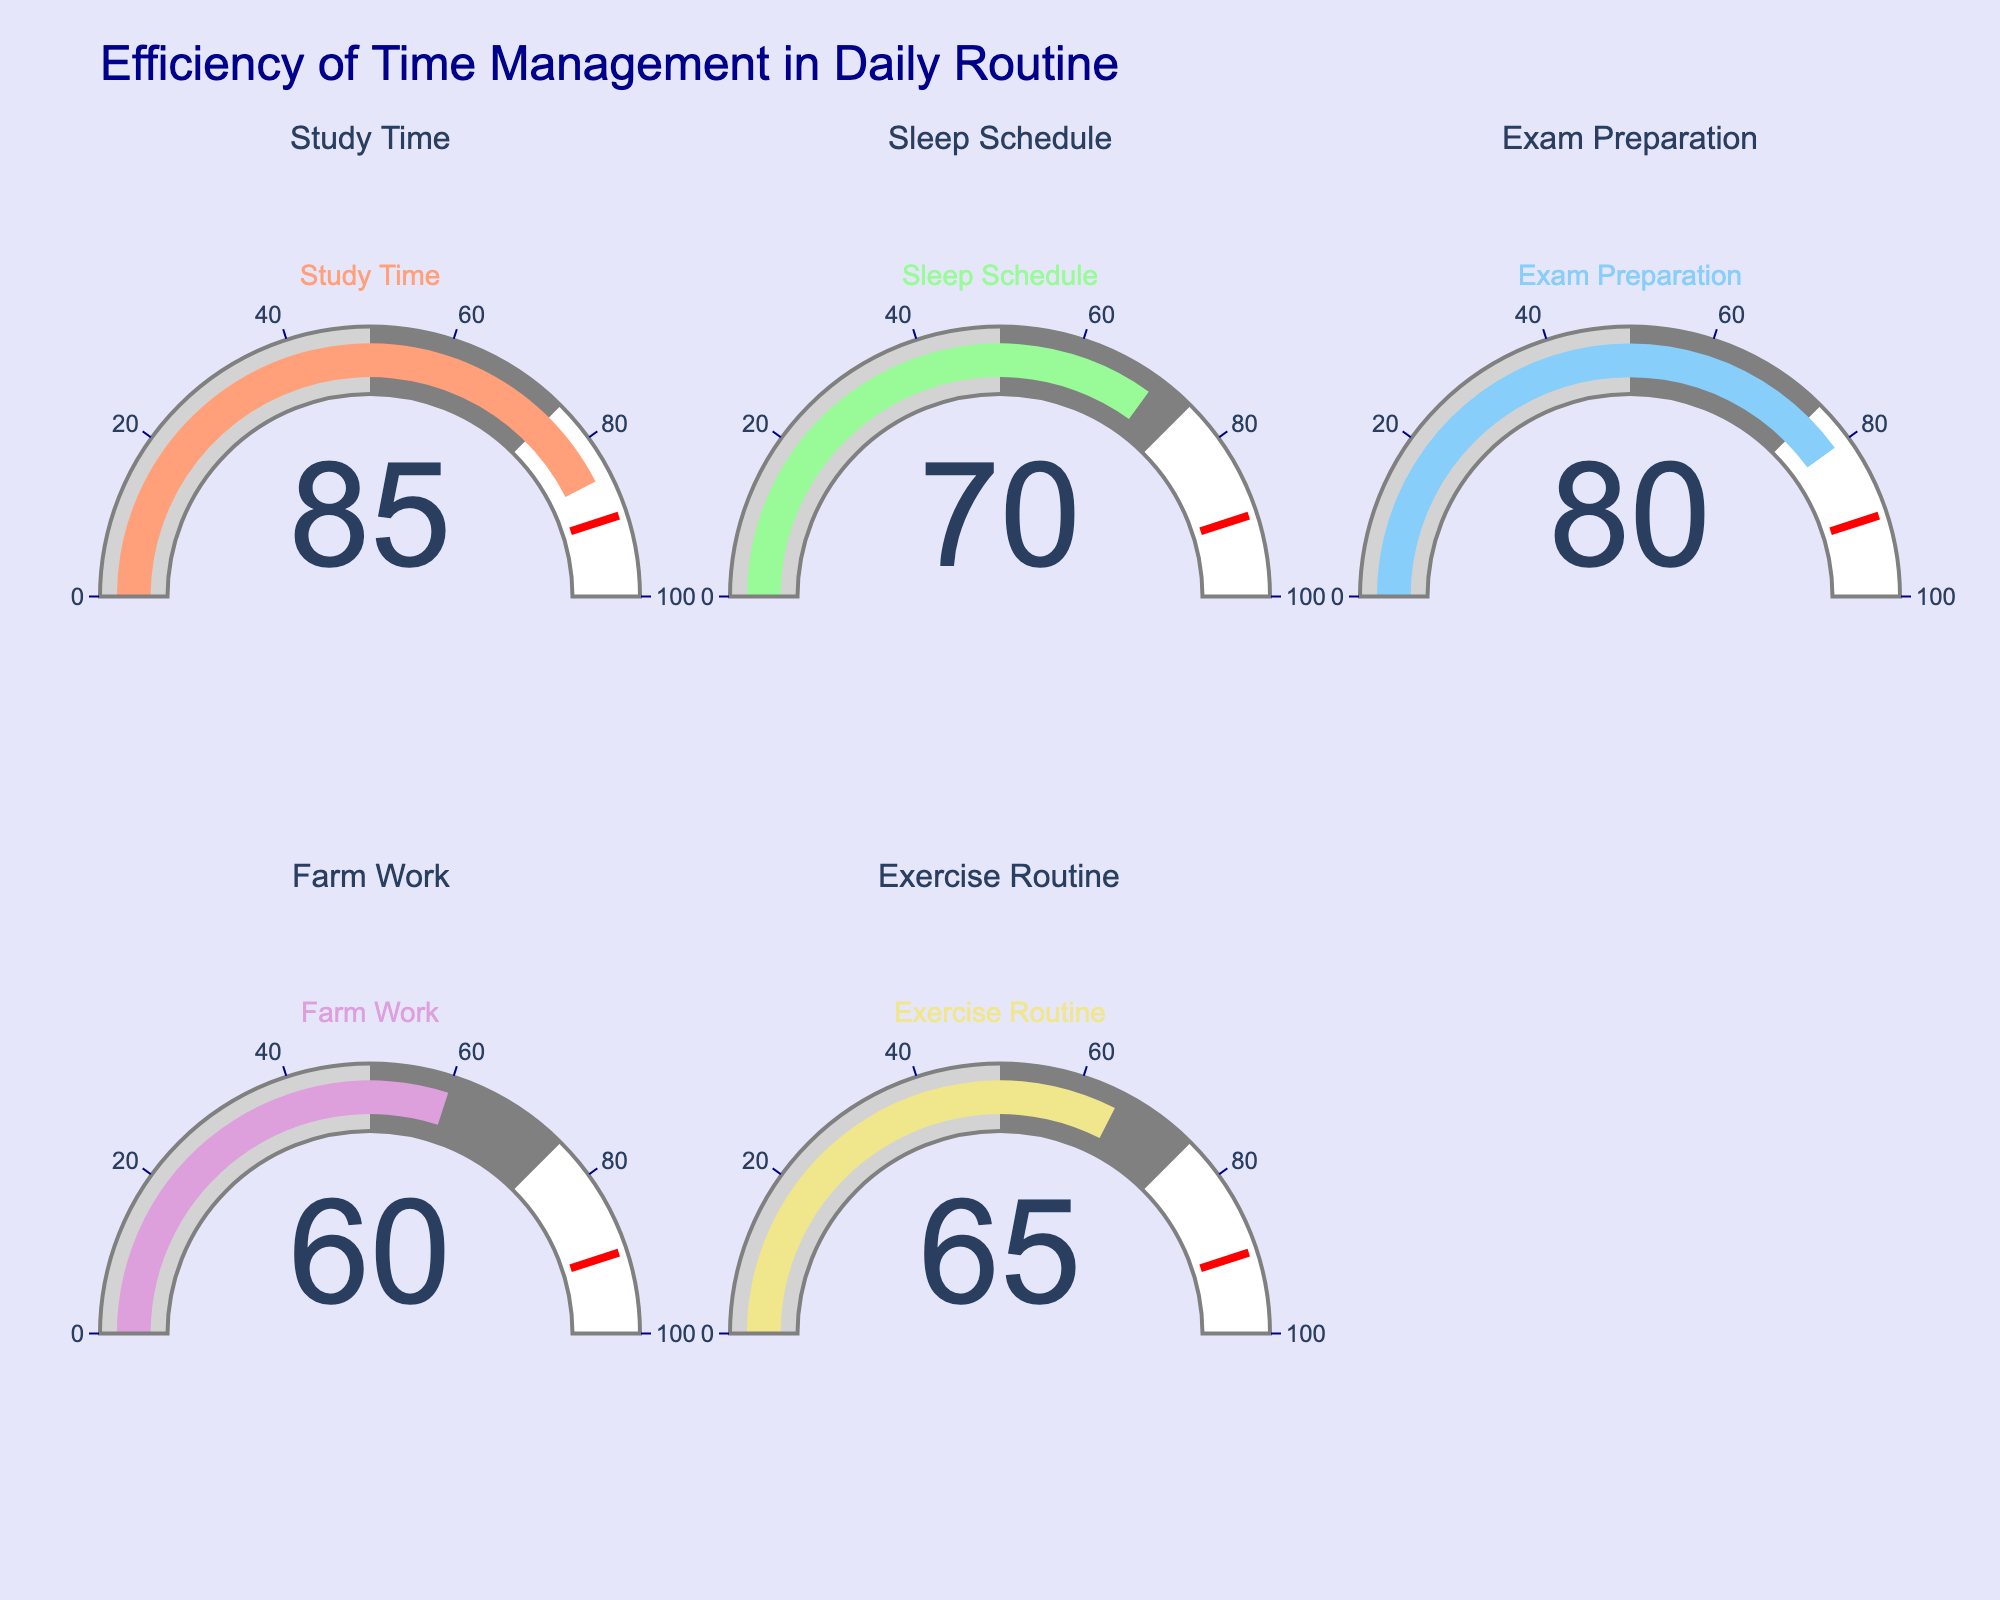What is the efficiency of Exam Preparation? The efficiency of Exam Preparation is given directly on the corresponding gauge on the figure.
Answer: 80 Which category has the highest efficiency? By comparing the values on each gauge, the highest efficiency is for Study Time at 85.
Answer: Study Time Which two categories have the lowest efficiencies? The two lowest efficiency values can be found by looking at the gauges for Farm Work (60) and Exercise Routine (65).
Answer: Farm Work and Exercise Routine What is the combined efficiency of Study Time and Sleep Schedule? Add the efficiencies shown on the gauges for Study Time (85) and Sleep Schedule (70). 85 + 70 = 155
Answer: 155 What is the average efficiency of all categories? Sum all efficiencies (85, 70, 80, 60, 65) and divide by the number of categories (5). (85 + 70 + 80 + 60 + 65) / 5 = 72
Answer: 72 How much higher is the efficiency of Exercise Routine compared to Farm Work? Subtract the efficiency of Farm Work from Exercise Routine. 65 - 60 = 5
Answer: 5 Which category has a efficiency closest to 70? Compare values to 70, the closest efficiency is Sleep Schedule with a value of 70.
Answer: Sleep Schedule What is the range of the efficiencies shown in the gauges? Subtract the minimum efficiency (Farm Work: 60) from the maximum (Study Time: 85). 85 - 60 = 25
Answer: 25 How does the efficiency of Study Time compare to Exam Preparation? Comparing the gauges shows that Study Time is higher than Exam Preparation (85 vs. 80).
Answer: Study Time is higher Which efficiency is closest to the threshold value set in the figure (90)? The efficiency closest to the threshold (90) can be found by looking at the values, which is Study Time (85).
Answer: Study Time 